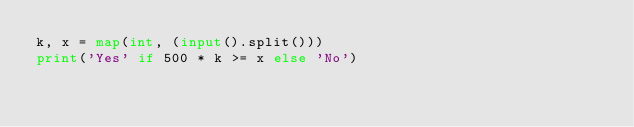Convert code to text. <code><loc_0><loc_0><loc_500><loc_500><_Python_>k, x = map(int, (input().split()))
print('Yes' if 500 * k >= x else 'No')
</code> 